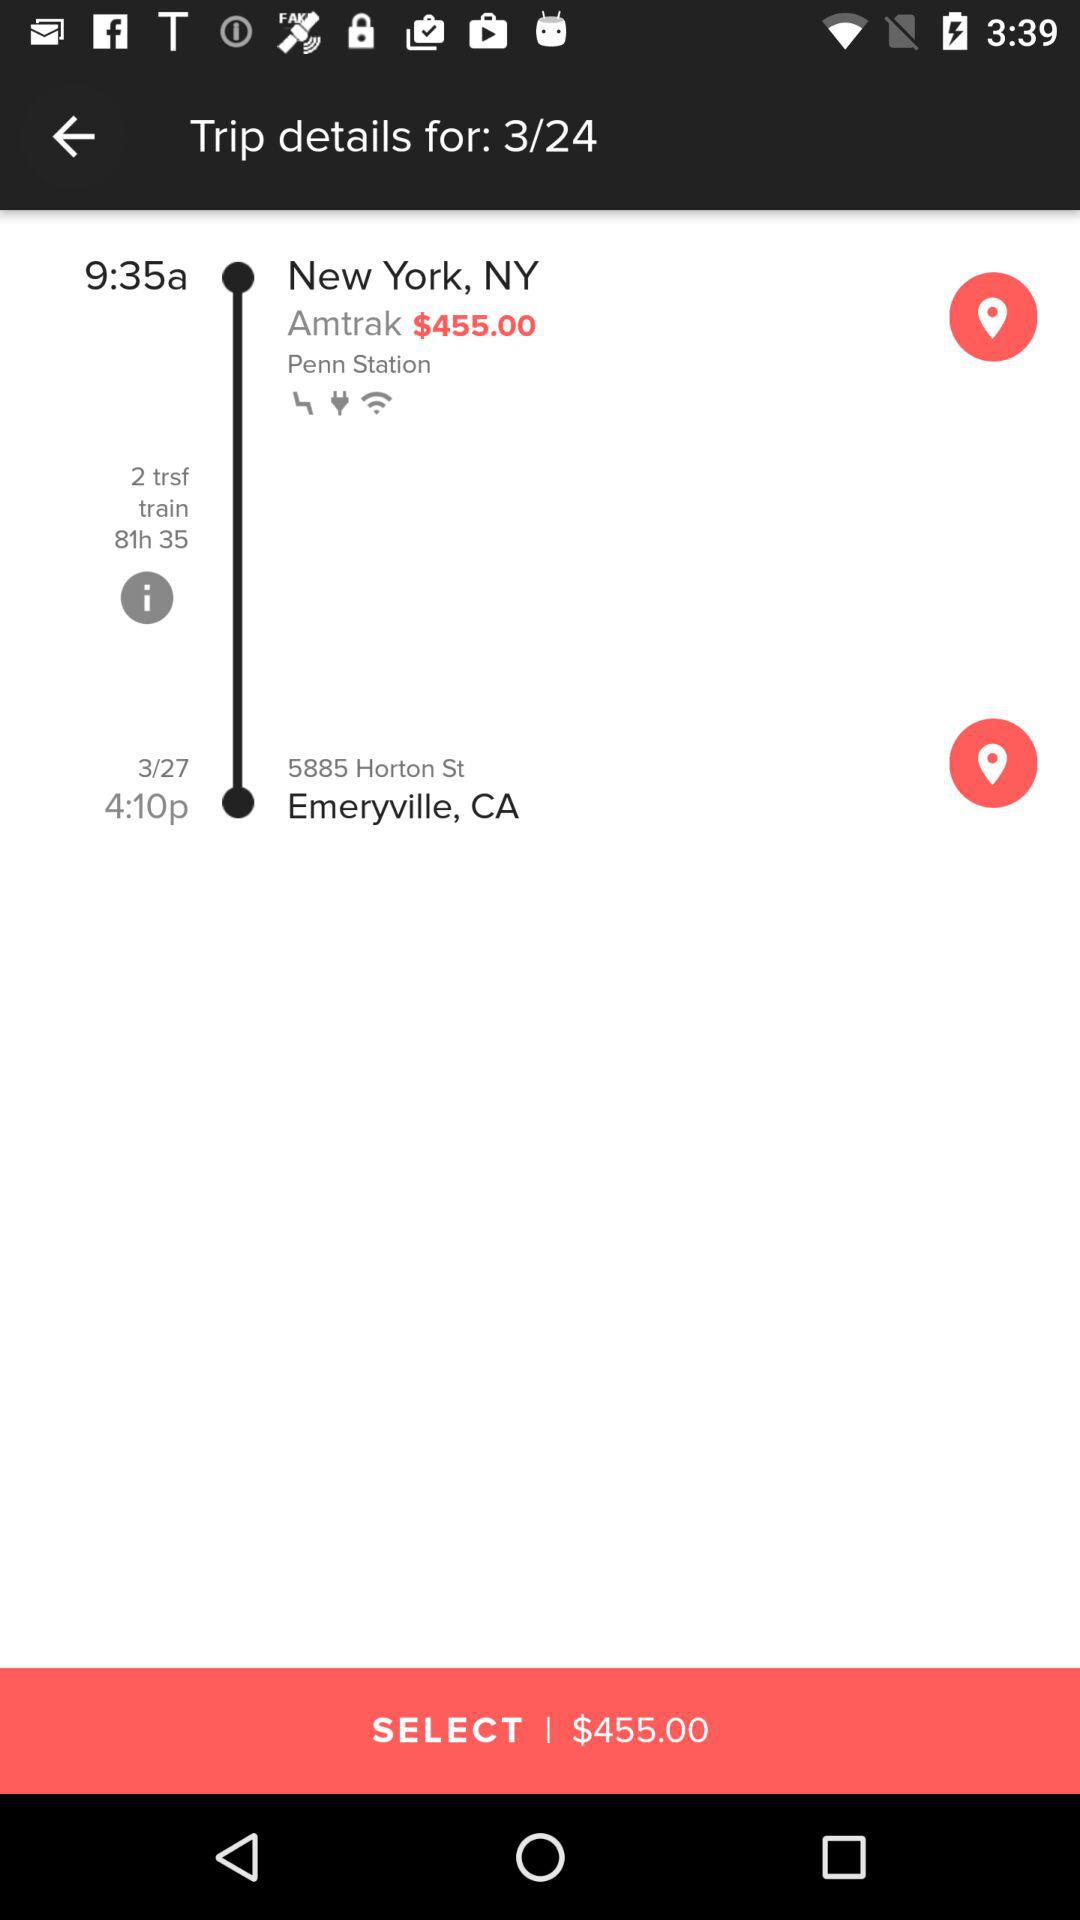Where is it to? It is to Emeryville, CA. 